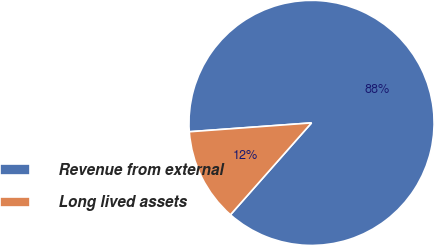<chart> <loc_0><loc_0><loc_500><loc_500><pie_chart><fcel>Revenue from external<fcel>Long lived assets<nl><fcel>87.66%<fcel>12.34%<nl></chart> 